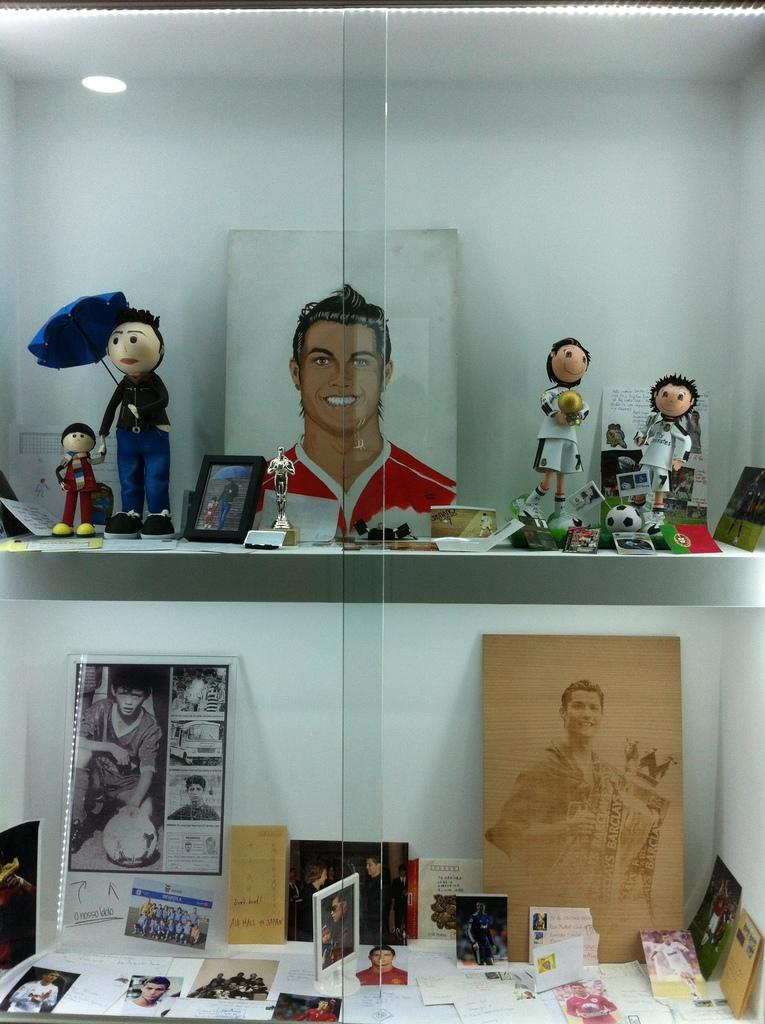What objects are present in the image that have a frame? There are frames in the image. What type of objects are depicted within the frames? The provided facts do not specify what is inside the frames. What other items can be seen in the image? There are toys and glass visible in the image. Can you describe the light source in the image? There is a light in the image. How does the kitten interact with the glue on the island in the image? There is no kitten, glue, or island present in the image. 